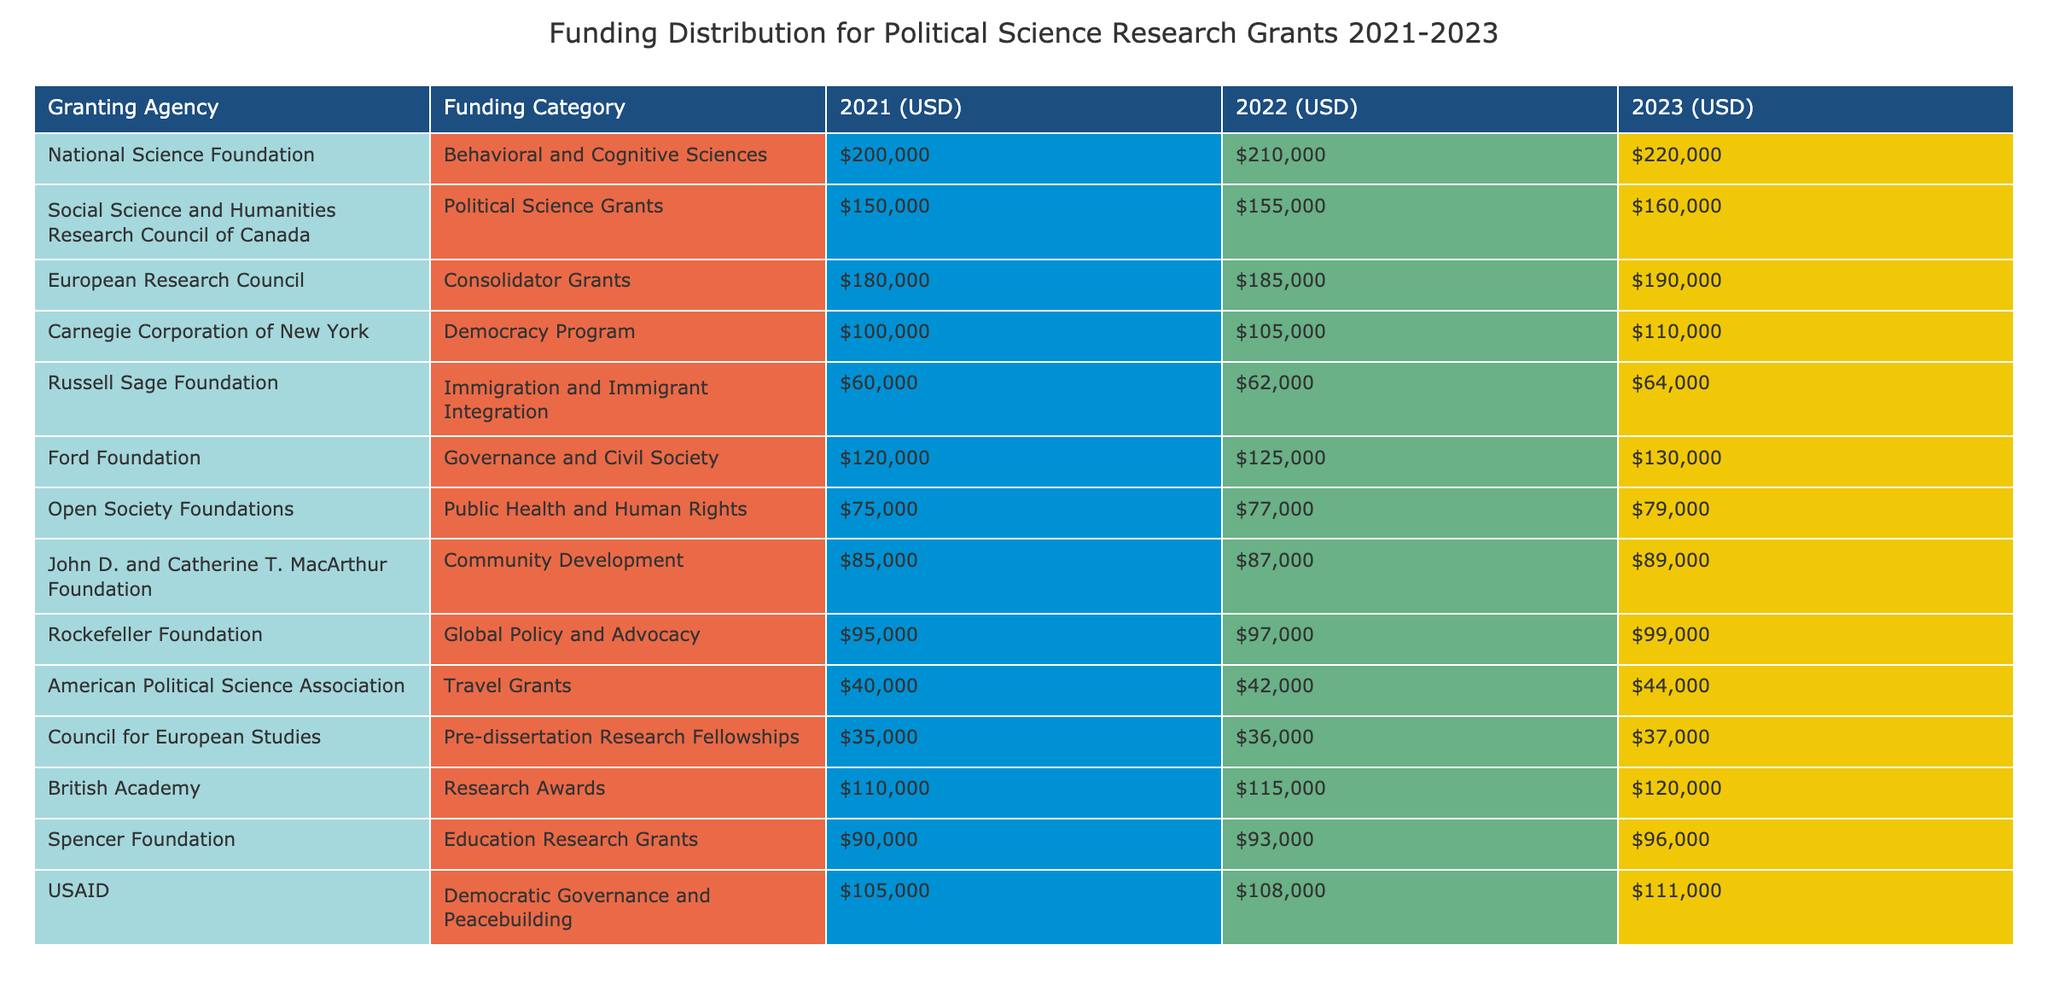What was the total funding for the National Science Foundation in 2022? The value for the National Science Foundation in 2022 is represented in the '2022 (USD)' column, which shows the amount of $210,000.
Answer: $210,000 What is the funding difference for the Carnegie Corporation of New York from 2021 to 2023? To find the difference, subtract the 2021 funding ($100,000) from the 2023 funding ($110,000): $110,000 - $100,000 = $10,000.
Answer: $10,000 Did the Ford Foundation receive more funding in 2023 than in 2021? The Ford Foundation received $130,000 in 2023 and $120,000 in 2021. Since $130,000 is greater than $120,000, the answer is yes.
Answer: Yes What is the average funding received by the Russell Sage Foundation over the three years? The funding amounts for the Russell Sage Foundation are $60,000 (2021), $62,000 (2022), and $64,000 (2023). Sum these values: $60,000 + $62,000 + $64,000 = $186,000, then divide by 3 to find the average: $186,000 / 3 = $62,000.
Answer: $62,000 What was the total amount of funding for Political Science Grants from 2021 to 2023? Add the values for Political Science Grants: 2021 ($150,000) + 2022 ($155,000) + 2023 ($160,000) = $150,000 + $155,000 + $160,000 = $465,000.
Answer: $465,000 Which granting agency had the highest funding in 2023? By examining the 2023 column, the National Science Foundation has the highest value at $220,000 compared to the others.
Answer: National Science Foundation Is the funding from the British Academy increasing every year? The amounts are $110,000 (2021), $115,000 (2022), and $120,000 (2023). Since each subsequent year shows an increase, the answer is yes.
Answer: Yes What was the total funding allocated to travel grants over the three years? The amounts for the American Political Science Association's travel grants are $40,000 (2021), $42,000 (2022), and $44,000 (2023). Adding these: $40,000 + $42,000 + $44,000 = $126,000.
Answer: $126,000 